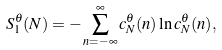<formula> <loc_0><loc_0><loc_500><loc_500>S _ { 1 } ^ { \theta } ( N ) = - \sum _ { n = - \infty } ^ { \infty } c _ { N } ^ { \theta } ( n ) \ln c _ { N } ^ { \theta } ( n ) ,</formula> 